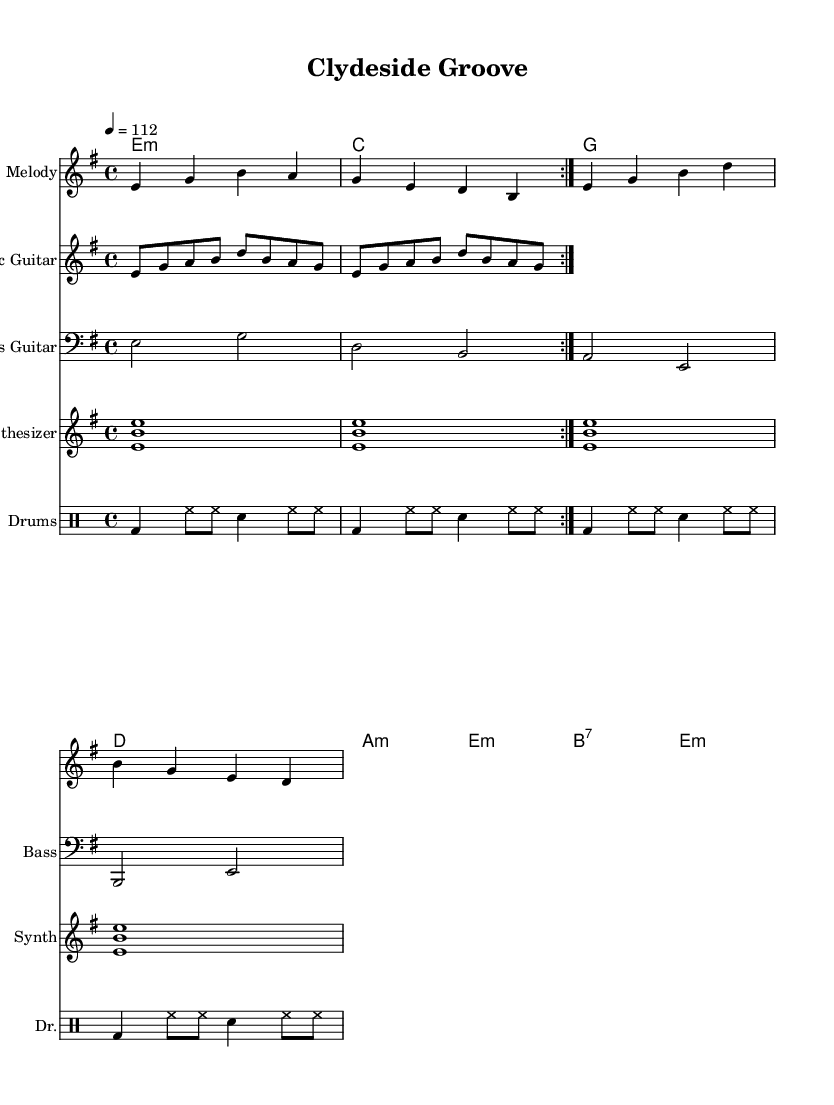What is the key signature of this music? The key signature is indicated by the presence of one sharp, which typically denotes E minor or G major. In this part, the music is primarily focused on E minor.
Answer: E minor What is the time signature of this music? The time signature is shown at the beginning of the score, represented as 4/4, meaning four beats per measure and a quarter note gets one beat.
Answer: 4/4 What is the tempo marking of this piece? The tempo marking is found next to the time signature, and it states "4 = 112," indicating that there are 112 beats per minute.
Answer: 112 How many measures are present in the electric guitar part? The electric guitar part has a repeat sign indicating it is played twice, with a measure count totaling 8 individual measures across both repetitions.
Answer: 8 What is the primary instrument that plays the melody? The melody part is labeled as a separate staff, explicitly stating "Melody," with notes indicating its primary instrument role throughout the piece.
Answer: Melody Which bass note appears most frequently in the bass guitar part? By examining the bass guitar part, the note "E" appears in multiple measures, establishing it as a recurring tone throughout the structure.
Answer: E How many different drum patterns are utilized in the score? The drum part shows a consistent repeating pattern throughout all measures, and since there's only one pattern, it indicates uniformity rather than multiple patterns.
Answer: 1 